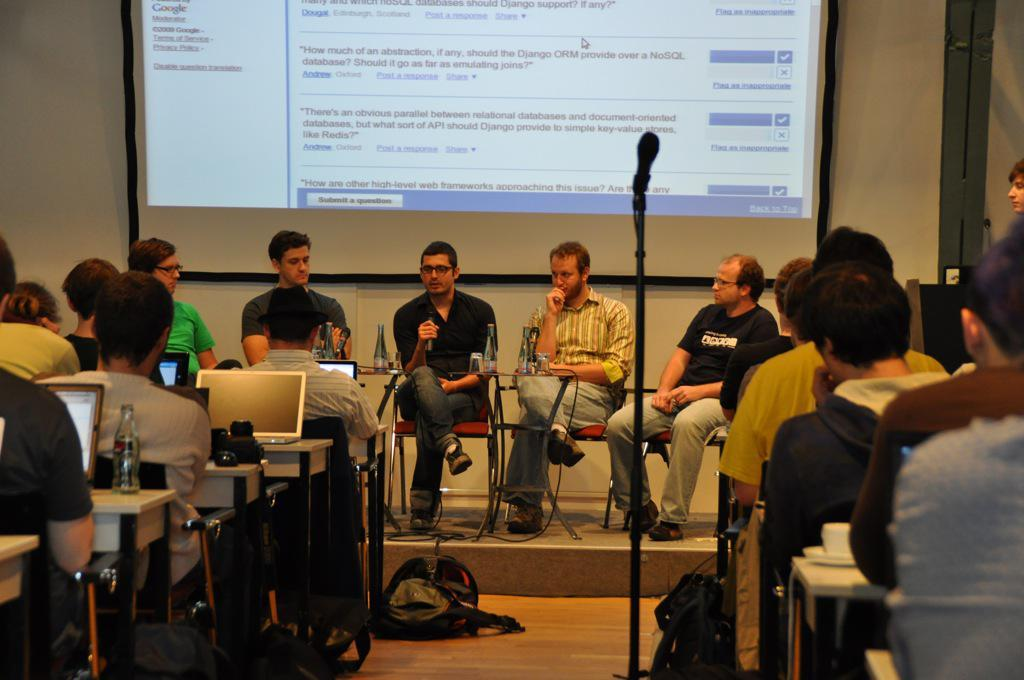How many people are in the image? There is a group of people in the image. What are the people doing in the image? The people are sitting on chairs. What can be seen on the desk in the image? There are laptops and water bottles on the desk. What object is used for amplifying sound in the image? There is a microphone in the image. What is on the floor in the image? There is a bag on the floor. What type of paper is being used by the cat in the image? There is no cat present in the image, so there is no paper being used by a cat. 